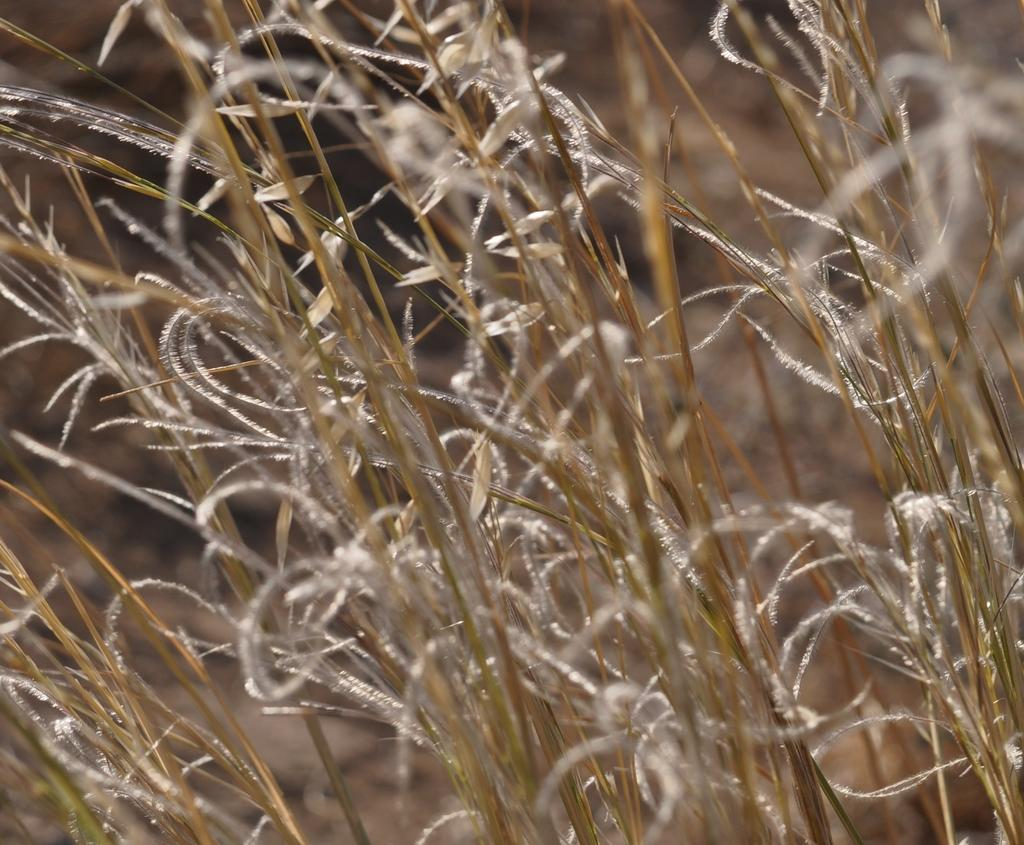What type of vegetation can be seen in the image? There is dry grass in the image. What type of birthday celebration is taking place in the image? There is no indication of a birthday celebration in the image, as it only features dry grass. Can you see a pig in the image? There is no pig present in the image; it only features dry grass. 